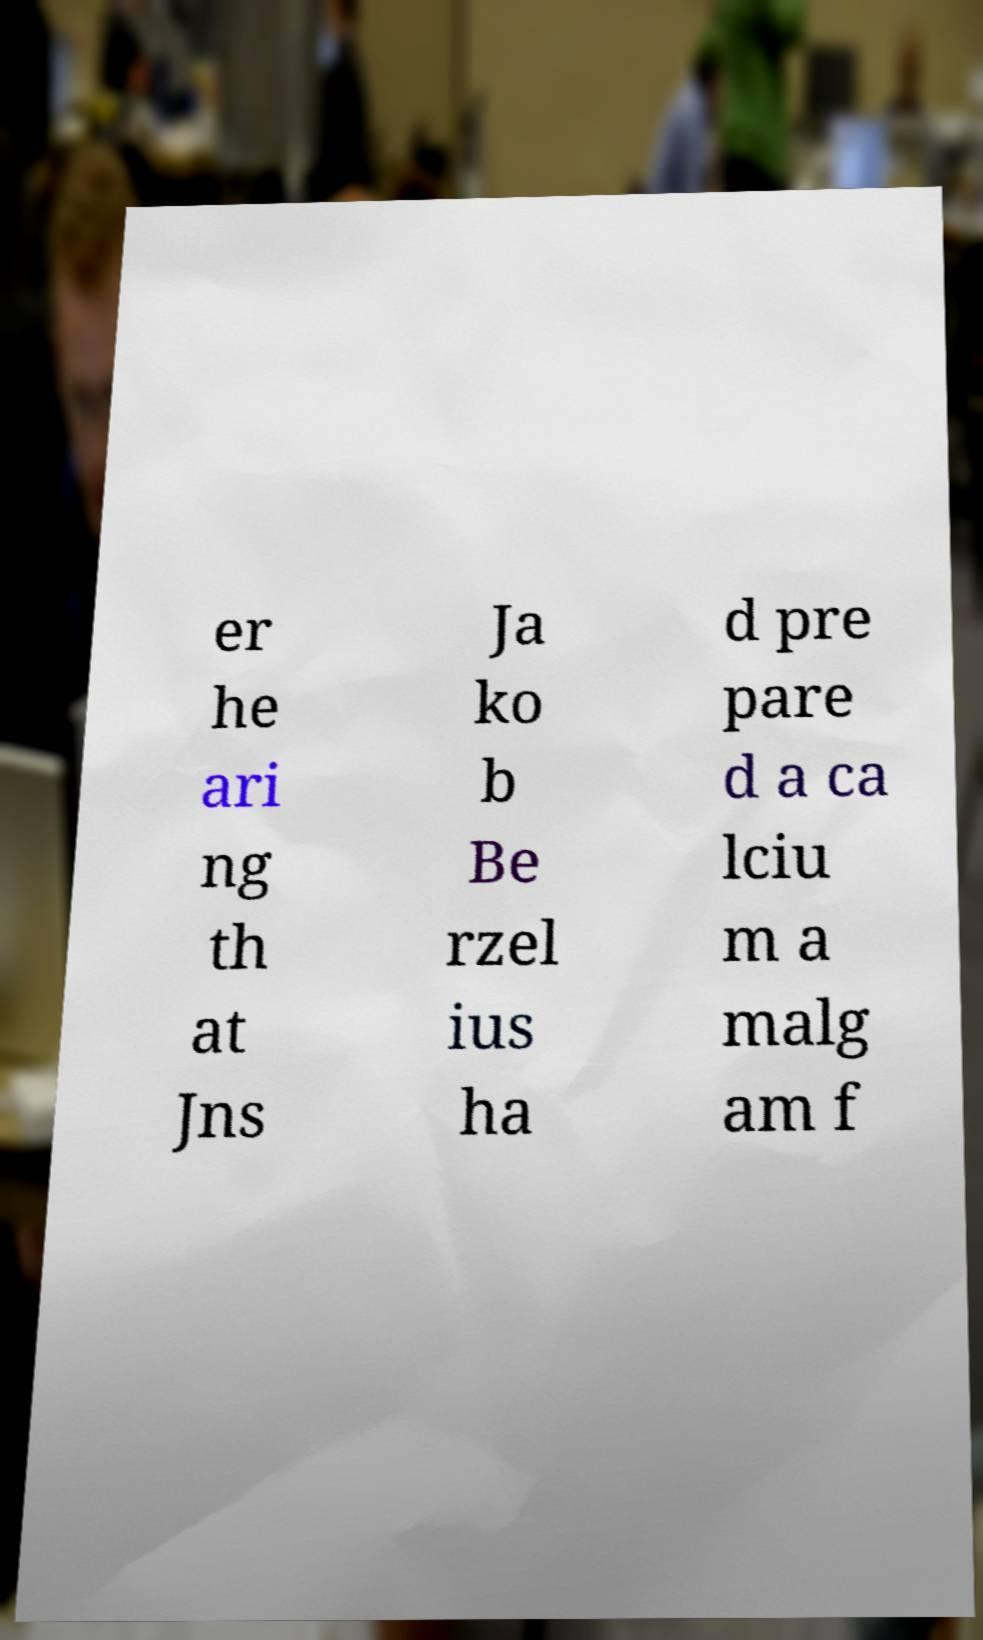For documentation purposes, I need the text within this image transcribed. Could you provide that? er he ari ng th at Jns Ja ko b Be rzel ius ha d pre pare d a ca lciu m a malg am f 